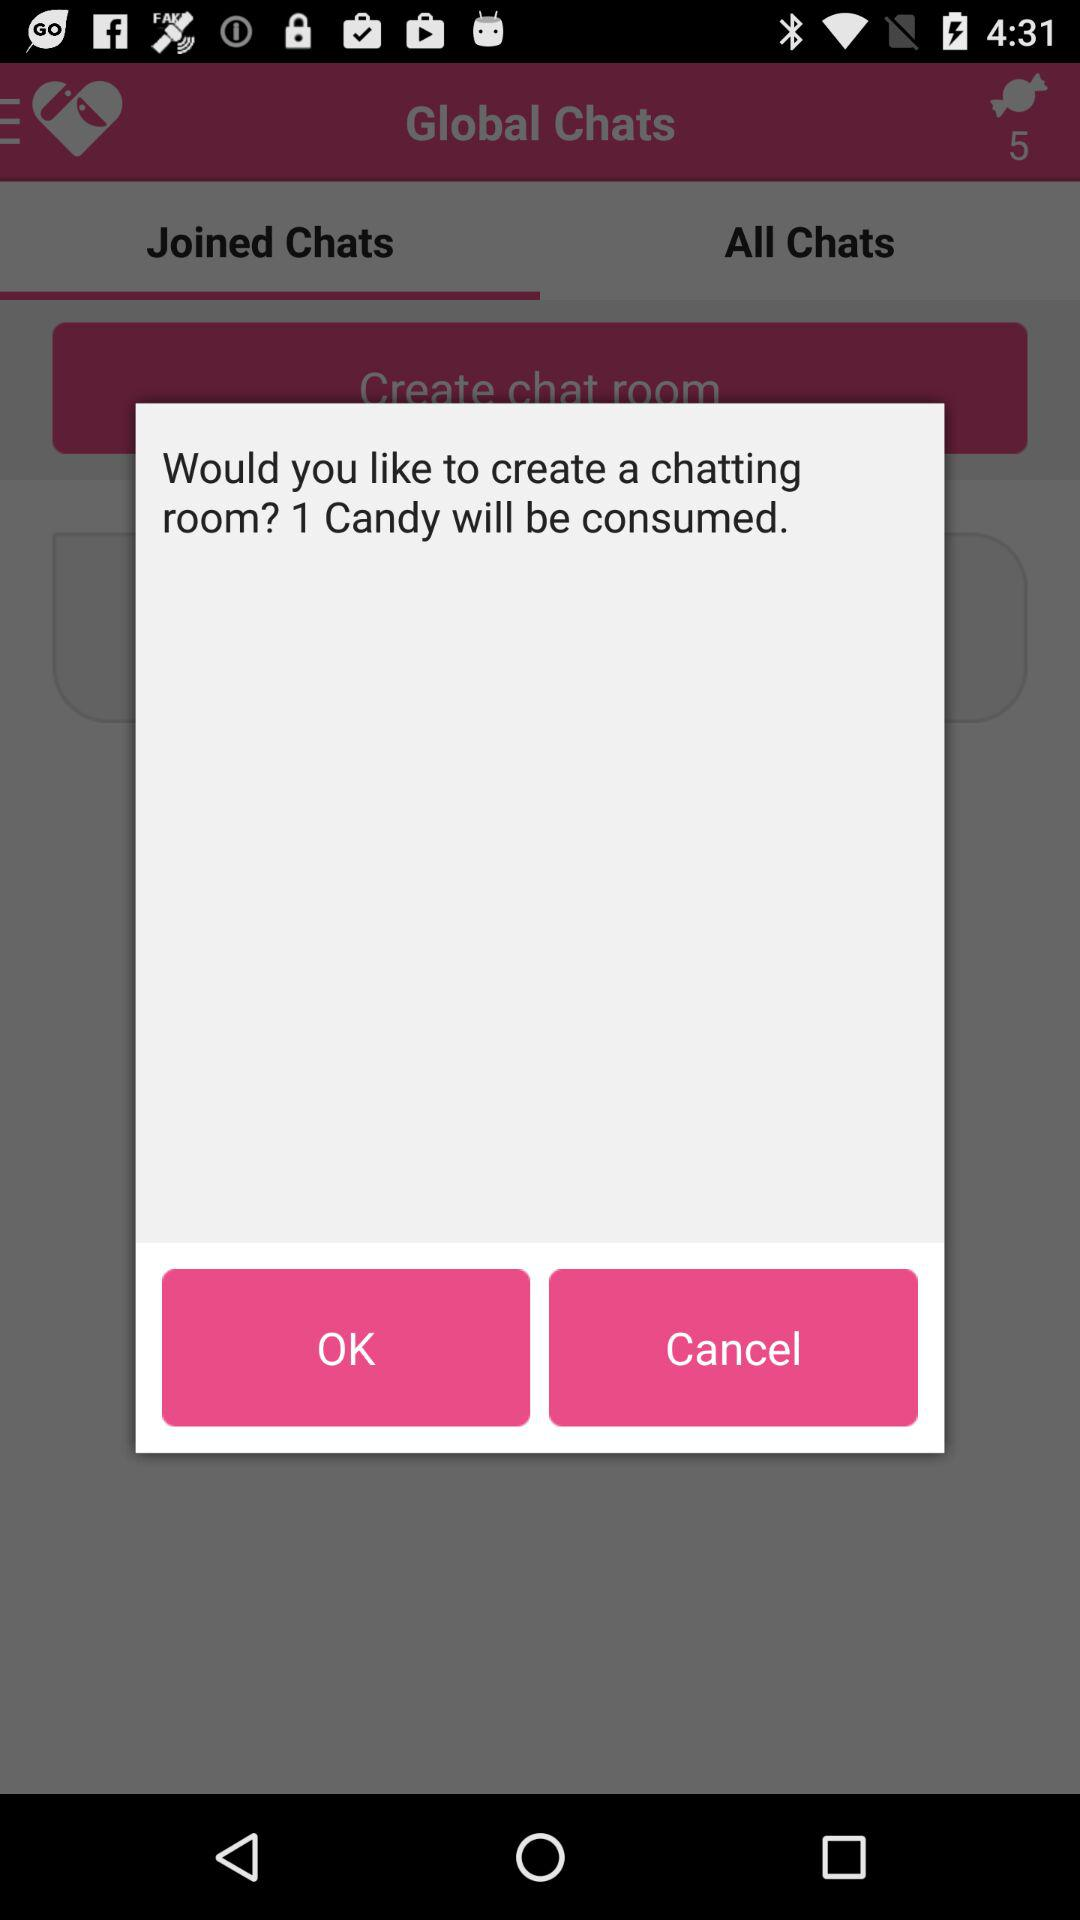How much candy will be consumed to create a chat room? To create a chat room, 1 candy will be consumed. 